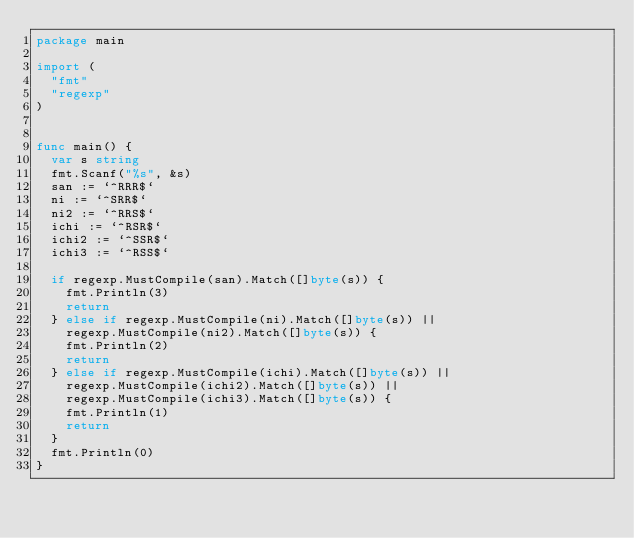<code> <loc_0><loc_0><loc_500><loc_500><_Go_>package main

import (
	"fmt"
	"regexp"
)


func main() {
	var s string
	fmt.Scanf("%s", &s)
	san := `^RRR$`
	ni := `^SRR$`
	ni2 := `^RRS$`
	ichi := `^RSR$`
	ichi2 := `^SSR$`
	ichi3 := `^RSS$`

	if regexp.MustCompile(san).Match([]byte(s)) {
		fmt.Println(3)
		return
	} else if regexp.MustCompile(ni).Match([]byte(s)) ||
		regexp.MustCompile(ni2).Match([]byte(s)) {
		fmt.Println(2)
		return
	} else if regexp.MustCompile(ichi).Match([]byte(s)) ||
		regexp.MustCompile(ichi2).Match([]byte(s)) ||
		regexp.MustCompile(ichi3).Match([]byte(s)) {
		fmt.Println(1)
		return
	}
	fmt.Println(0)
}
</code> 